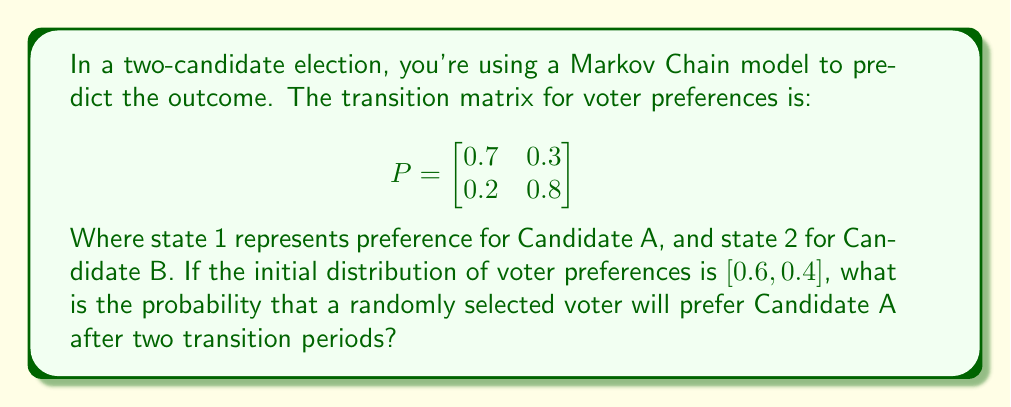Help me with this question. Let's approach this step-by-step:

1) We start with the initial distribution vector:
   $\pi_0 = [0.6, 0.4]$

2) To find the distribution after two transition periods, we need to multiply $\pi_0$ by $P$ twice:
   $\pi_2 = \pi_0 P^2$

3) First, let's calculate $P^2$:
   $$P^2 = \begin{bmatrix}
   0.7 & 0.3 \\
   0.2 & 0.8
   \end{bmatrix} \times \begin{bmatrix}
   0.7 & 0.3 \\
   0.2 & 0.8
   \end{bmatrix}$$

4) Multiplying these matrices:
   $$P^2 = \begin{bmatrix}
   (0.7 \times 0.7 + 0.3 \times 0.2) & (0.7 \times 0.3 + 0.3 \times 0.8) \\
   (0.2 \times 0.7 + 0.8 \times 0.2) & (0.2 \times 0.3 + 0.8 \times 0.8)
   \end{bmatrix}$$

5) Simplifying:
   $$P^2 = \begin{bmatrix}
   0.55 & 0.45 \\
   0.30 & 0.70
   \end{bmatrix}$$

6) Now, we multiply $\pi_0$ by $P^2$:
   $\pi_2 = [0.6, 0.4] \times \begin{bmatrix}
   0.55 & 0.45 \\
   0.30 & 0.70
   \end{bmatrix}$

7) Calculating:
   $\pi_2 = [0.6 \times 0.55 + 0.4 \times 0.30, 0.6 \times 0.45 + 0.4 \times 0.70]$
   $\pi_2 = [0.45, 0.55]$

8) The first element of $\pi_2$ represents the probability of preferring Candidate A after two transition periods.
Answer: 0.45 